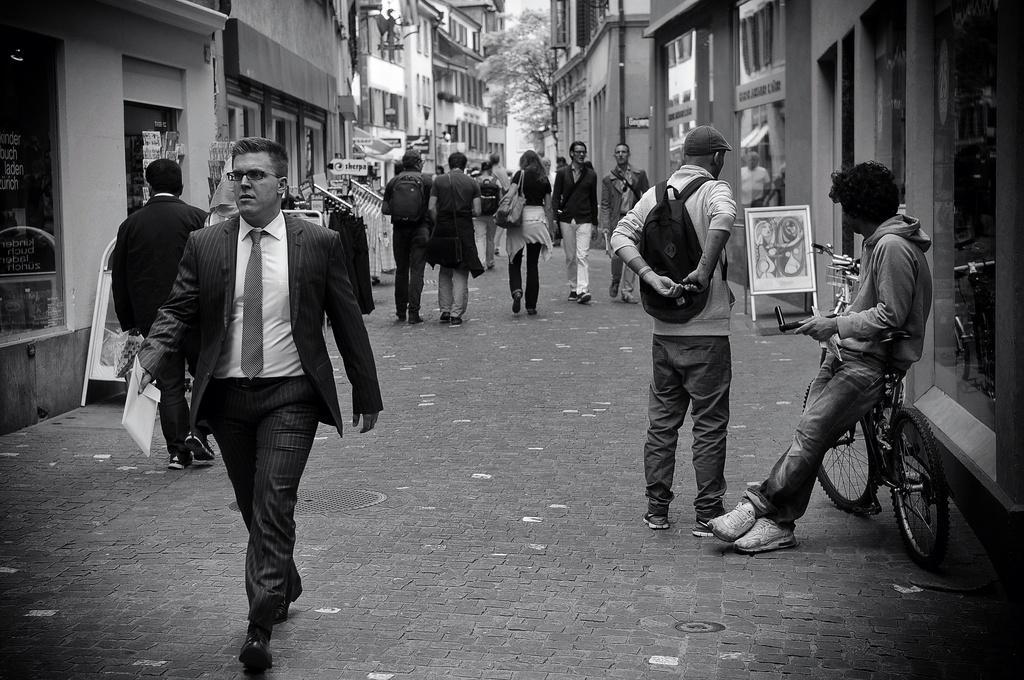Could you give a brief overview of what you see in this image? In this image there are group of persons walking, the persons are wearing a bag, they are holding an object, there are bicycles, there is a board, there is a painting on the board, there are buildings, there are windows, there is a tree, there is the sky, there is text on the boards. 